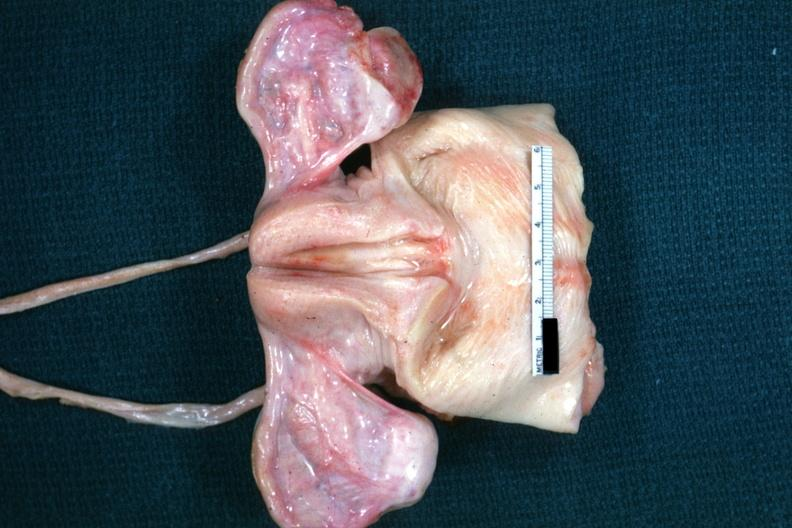what is present?
Answer the question using a single word or phrase. Female reproductive 